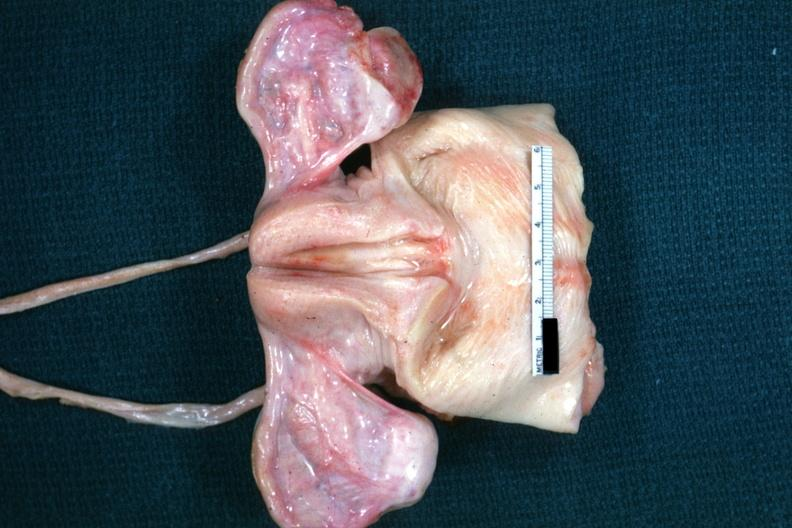what is present?
Answer the question using a single word or phrase. Female reproductive 